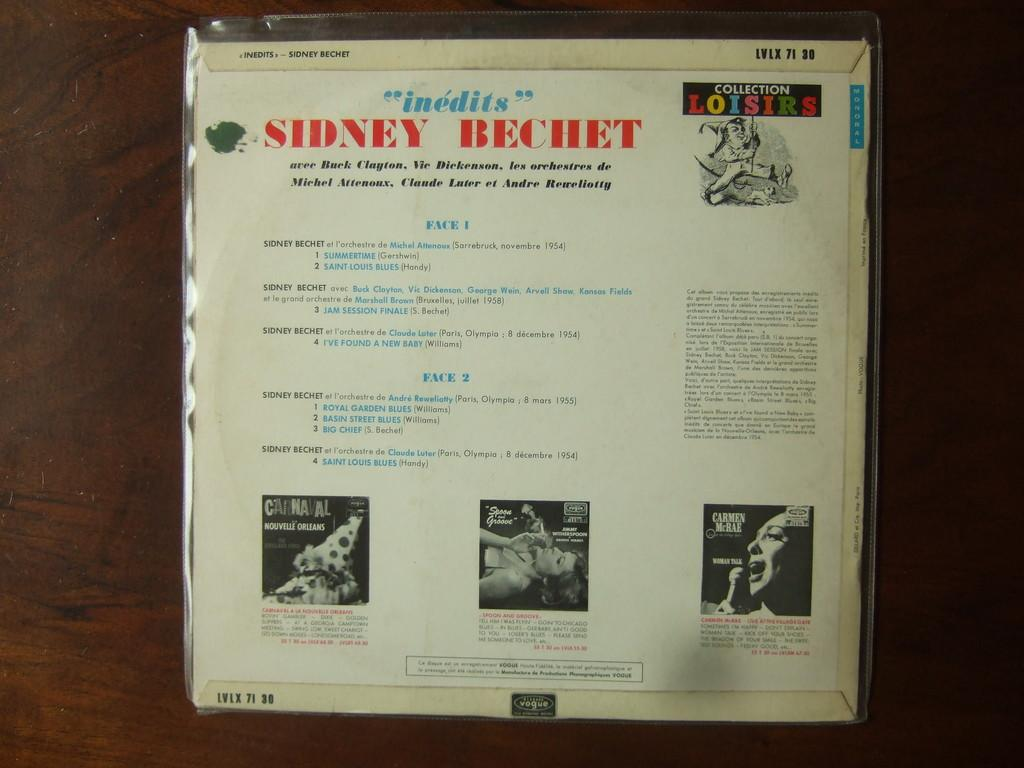<image>
Share a concise interpretation of the image provided. The back of an album by Sidney Bechet. 